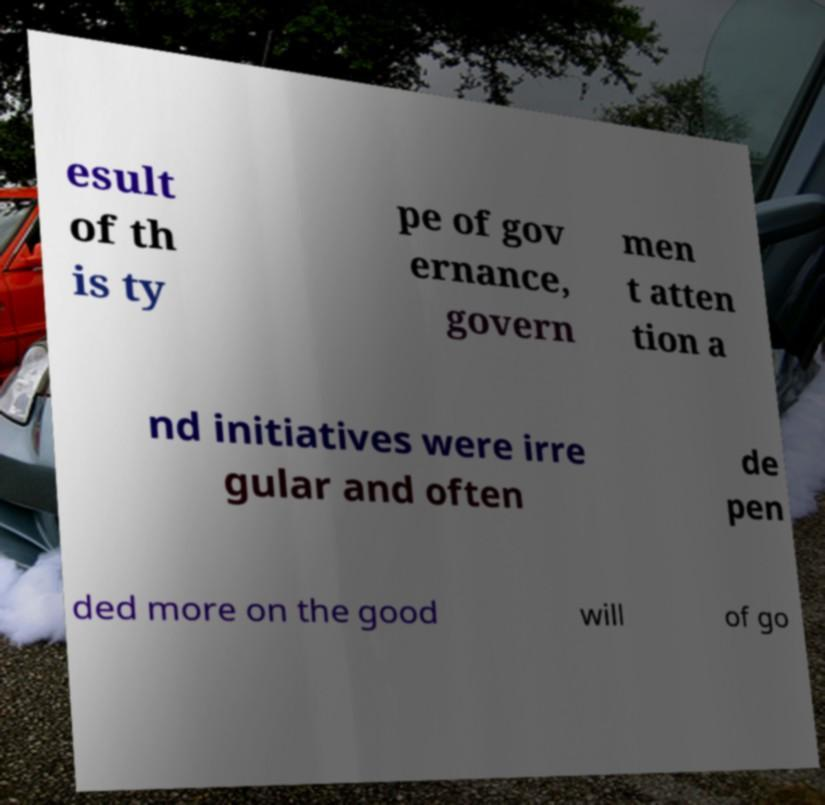There's text embedded in this image that I need extracted. Can you transcribe it verbatim? esult of th is ty pe of gov ernance, govern men t atten tion a nd initiatives were irre gular and often de pen ded more on the good will of go 